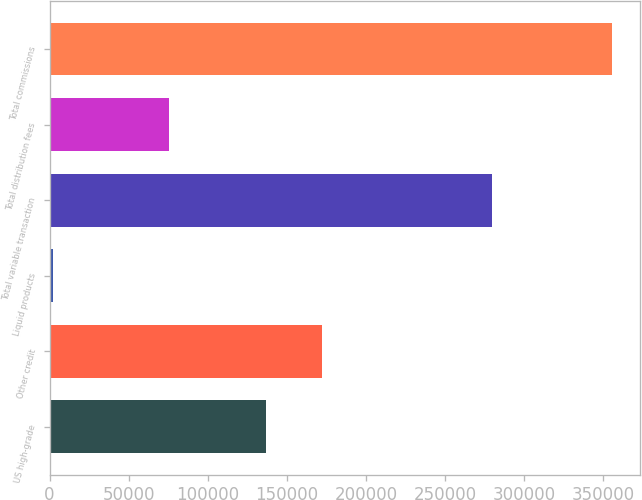Convert chart to OTSL. <chart><loc_0><loc_0><loc_500><loc_500><bar_chart><fcel>US high-grade<fcel>Other credit<fcel>Liquid products<fcel>Total variable transaction<fcel>Total distribution fees<fcel>Total commissions<nl><fcel>137034<fcel>172334<fcel>2277<fcel>279803<fcel>75479<fcel>355282<nl></chart> 